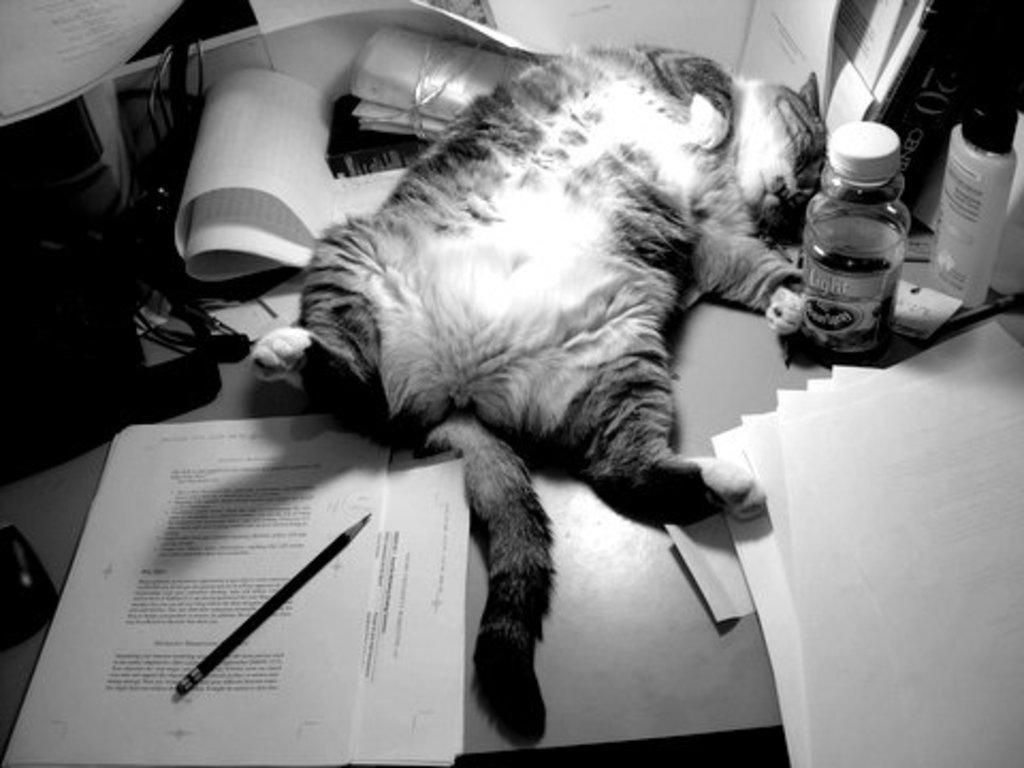Could you give a brief overview of what you see in this image? This is a black and white picture. Here we can see a cat, bottles, papers, pencil, cables, and a mouse on a table. 